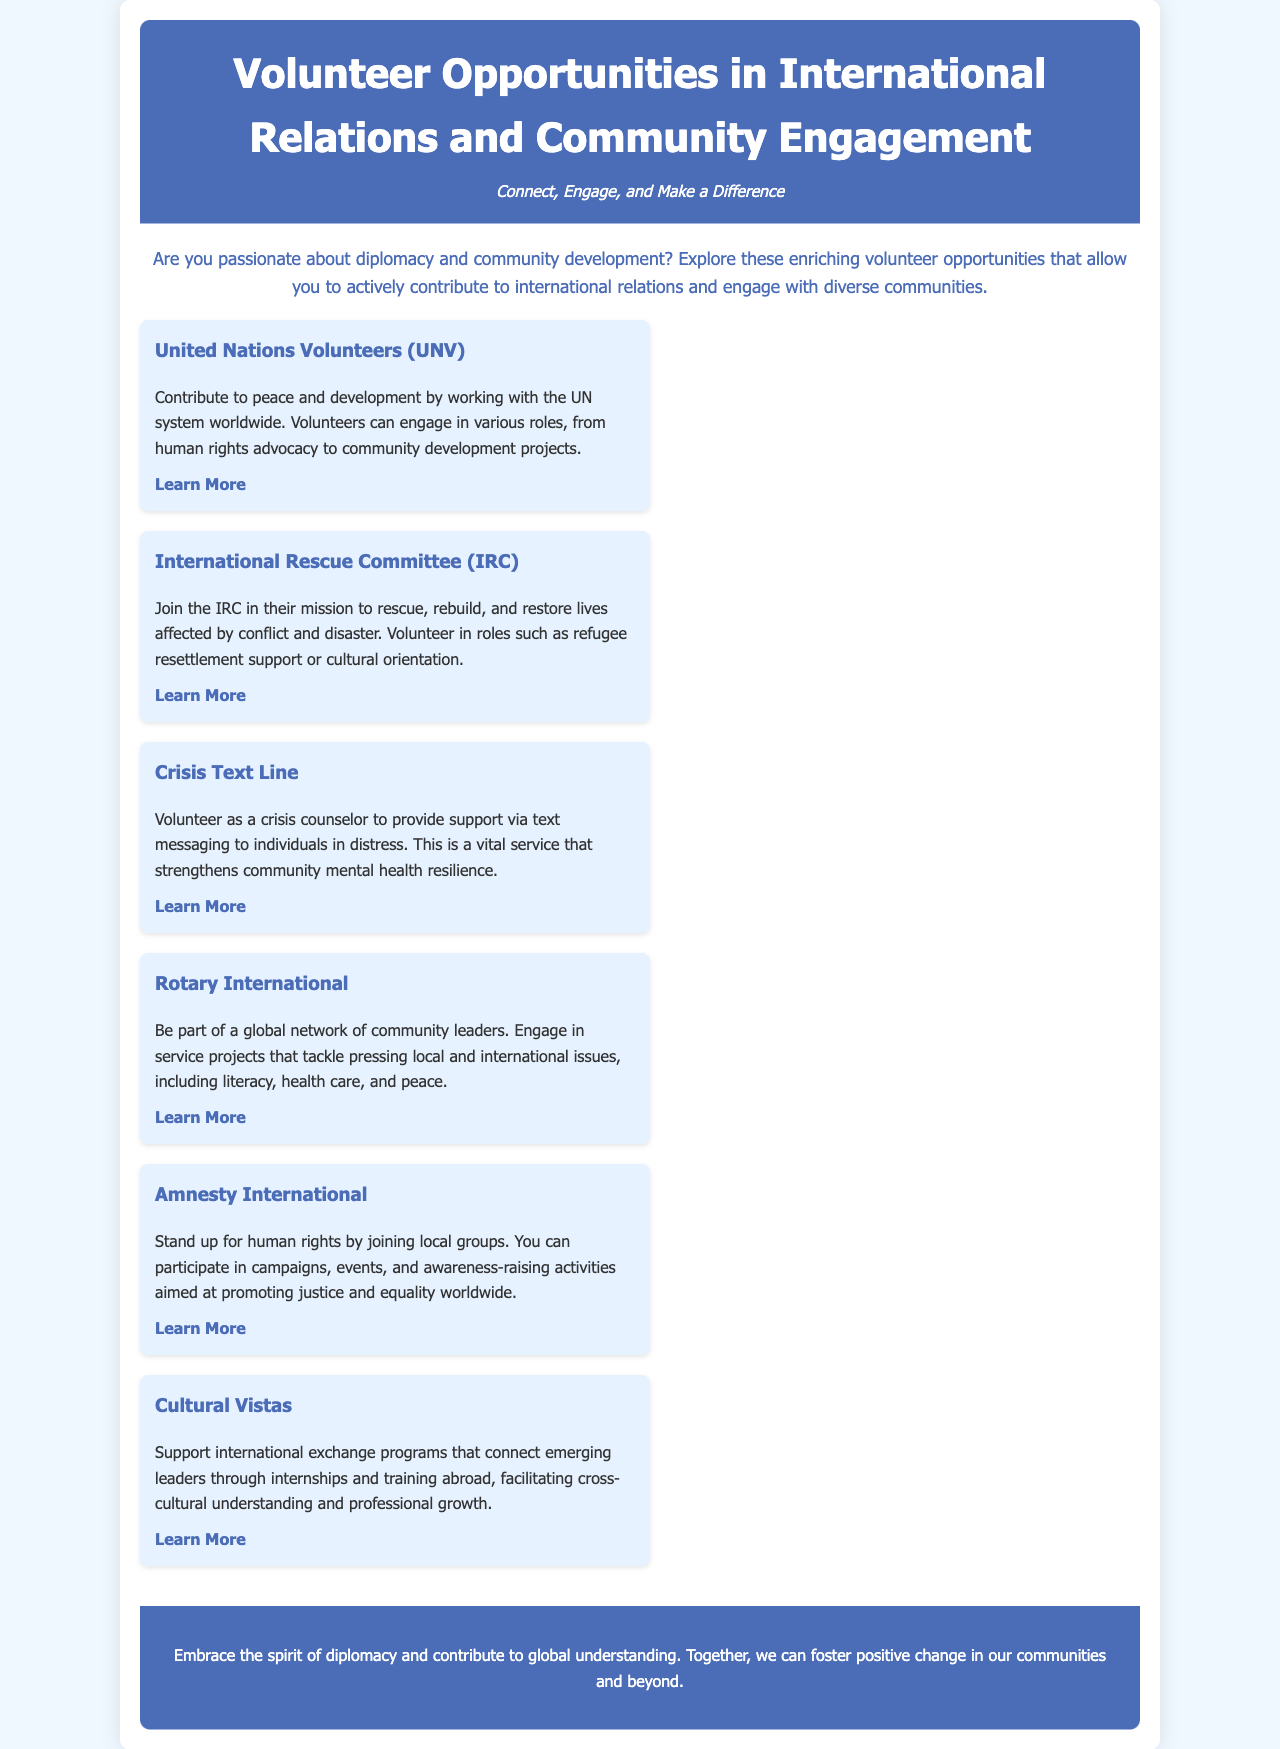What is the main theme of the brochure? The brochure encourages individuals to connect, engage, and make a difference through volunteering in international relations and community engagement.
Answer: Connect, Engage, and Make a Difference How many volunteer opportunities are listed in the document? There are six distinct volunteer opportunities highlighted in the document.
Answer: Six What organization focuses on peace and development? The United Nations Volunteers (UNV) organization emphasizes contributing to peace and development.
Answer: United Nations Volunteers (UNV) What role can volunteers take with the International Rescue Committee? Volunteers can engage in refugee resettlement support roles among other activities.
Answer: Refugee resettlement support Which organization allows you to volunteer as a crisis counselor? Crisis Text Line is the organization where you can volunteer as a crisis counselor.
Answer: Crisis Text Line What does Rotary International focus on? Rotary International engages in service projects that address local and international issues.
Answer: Service projects What sort of activities can volunteers join with Amnesty International? Volunteers can participate in campaigns, events, and awareness-raising activities.
Answer: Campaigns, events, and awareness-raising activities Which organization promotes international exchange programs? Cultural Vistas is the organization that supports international exchange programs.
Answer: Cultural Vistas 